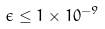Convert formula to latex. <formula><loc_0><loc_0><loc_500><loc_500>\epsilon \leq 1 \times 1 0 ^ { - 9 }</formula> 